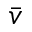Convert formula to latex. <formula><loc_0><loc_0><loc_500><loc_500>\bar { v }</formula> 